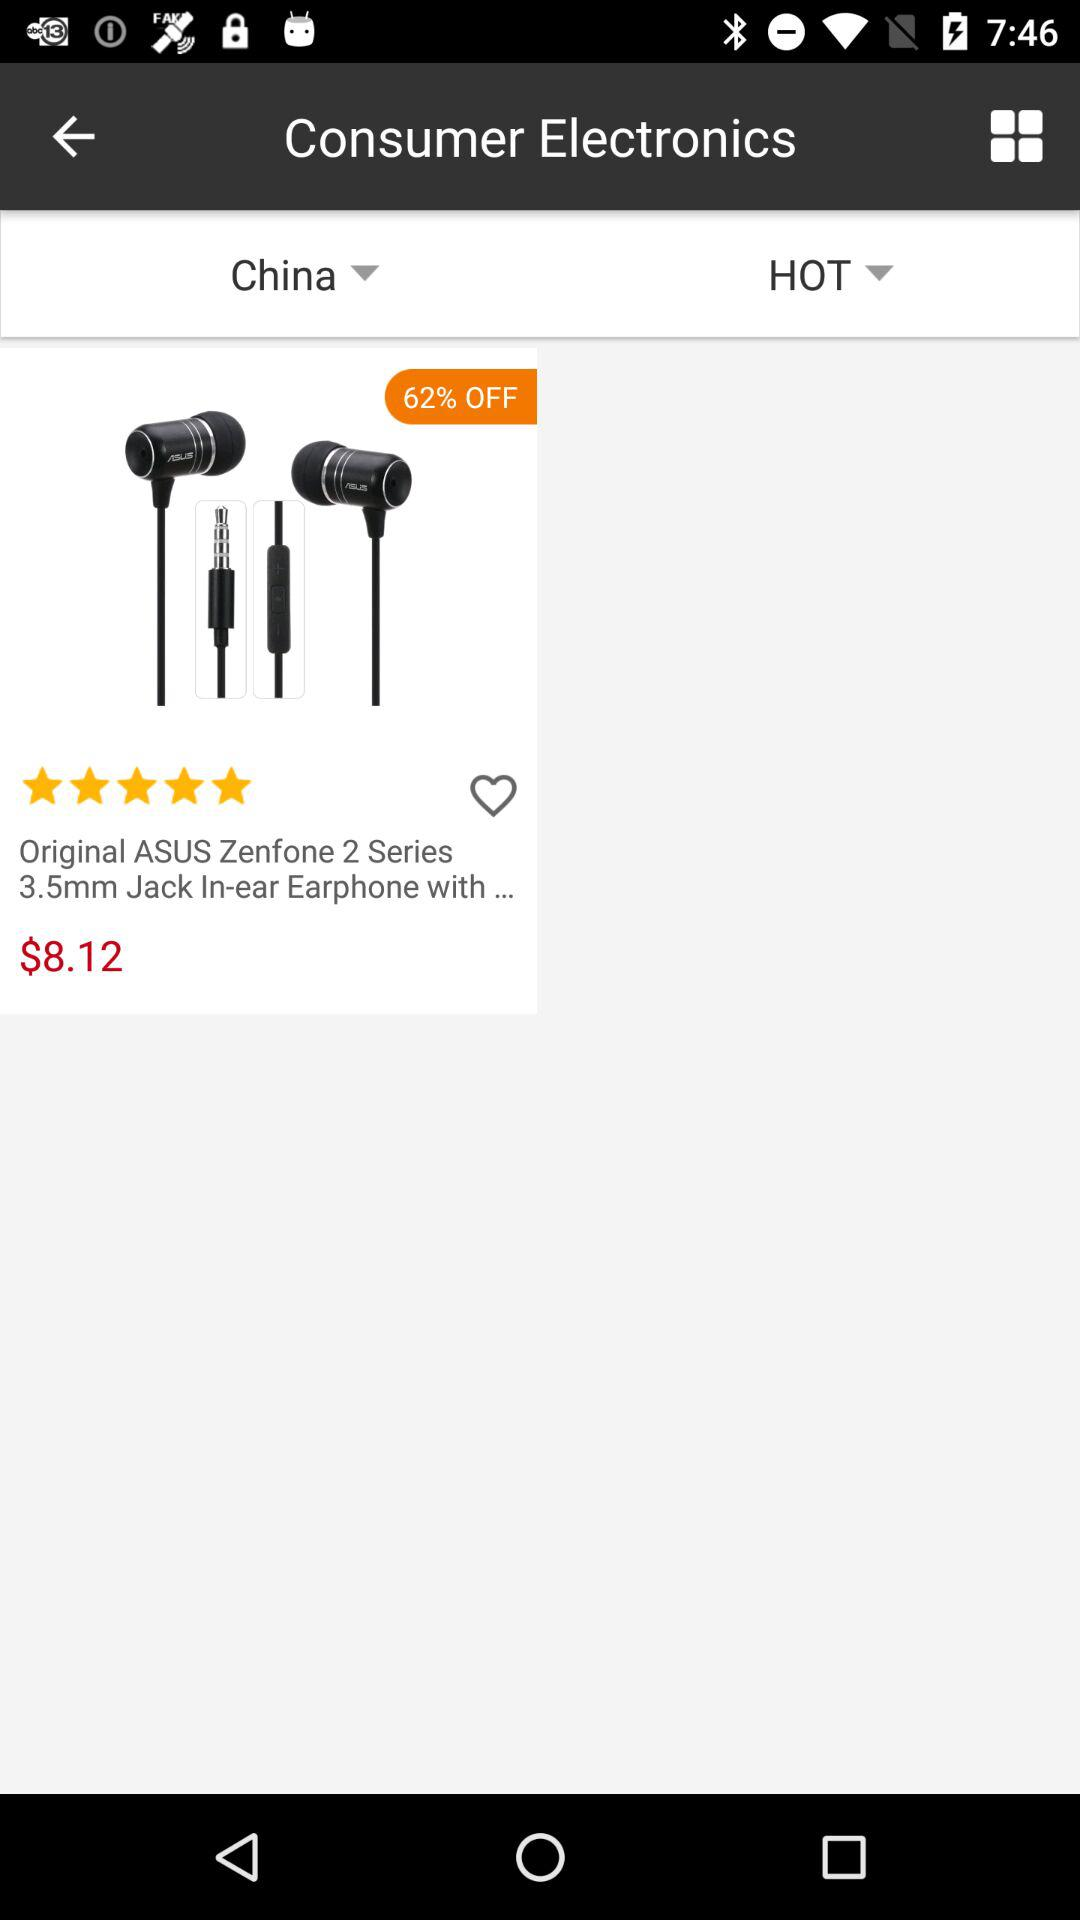What is the selected country? The selected country is China. 